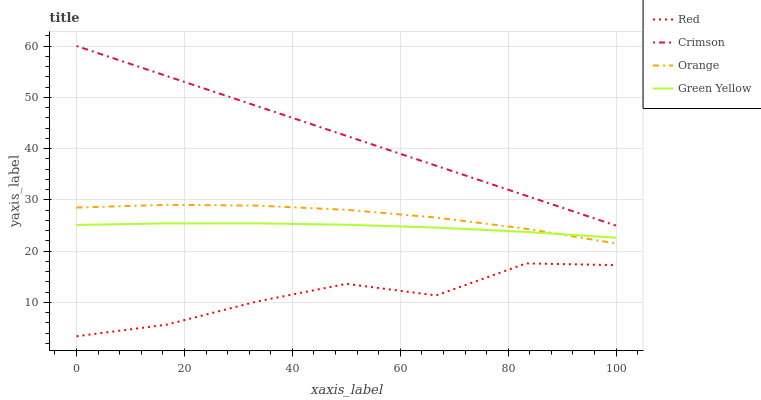Does Red have the minimum area under the curve?
Answer yes or no. Yes. Does Crimson have the maximum area under the curve?
Answer yes or no. Yes. Does Orange have the minimum area under the curve?
Answer yes or no. No. Does Orange have the maximum area under the curve?
Answer yes or no. No. Is Crimson the smoothest?
Answer yes or no. Yes. Is Red the roughest?
Answer yes or no. Yes. Is Orange the smoothest?
Answer yes or no. No. Is Orange the roughest?
Answer yes or no. No. Does Orange have the lowest value?
Answer yes or no. No. Does Crimson have the highest value?
Answer yes or no. Yes. Does Orange have the highest value?
Answer yes or no. No. Is Orange less than Crimson?
Answer yes or no. Yes. Is Crimson greater than Red?
Answer yes or no. Yes. Does Green Yellow intersect Orange?
Answer yes or no. Yes. Is Green Yellow less than Orange?
Answer yes or no. No. Is Green Yellow greater than Orange?
Answer yes or no. No. Does Orange intersect Crimson?
Answer yes or no. No. 